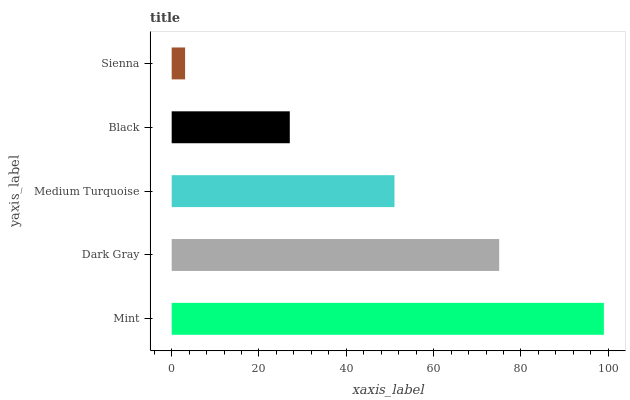Is Sienna the minimum?
Answer yes or no. Yes. Is Mint the maximum?
Answer yes or no. Yes. Is Dark Gray the minimum?
Answer yes or no. No. Is Dark Gray the maximum?
Answer yes or no. No. Is Mint greater than Dark Gray?
Answer yes or no. Yes. Is Dark Gray less than Mint?
Answer yes or no. Yes. Is Dark Gray greater than Mint?
Answer yes or no. No. Is Mint less than Dark Gray?
Answer yes or no. No. Is Medium Turquoise the high median?
Answer yes or no. Yes. Is Medium Turquoise the low median?
Answer yes or no. Yes. Is Dark Gray the high median?
Answer yes or no. No. Is Dark Gray the low median?
Answer yes or no. No. 